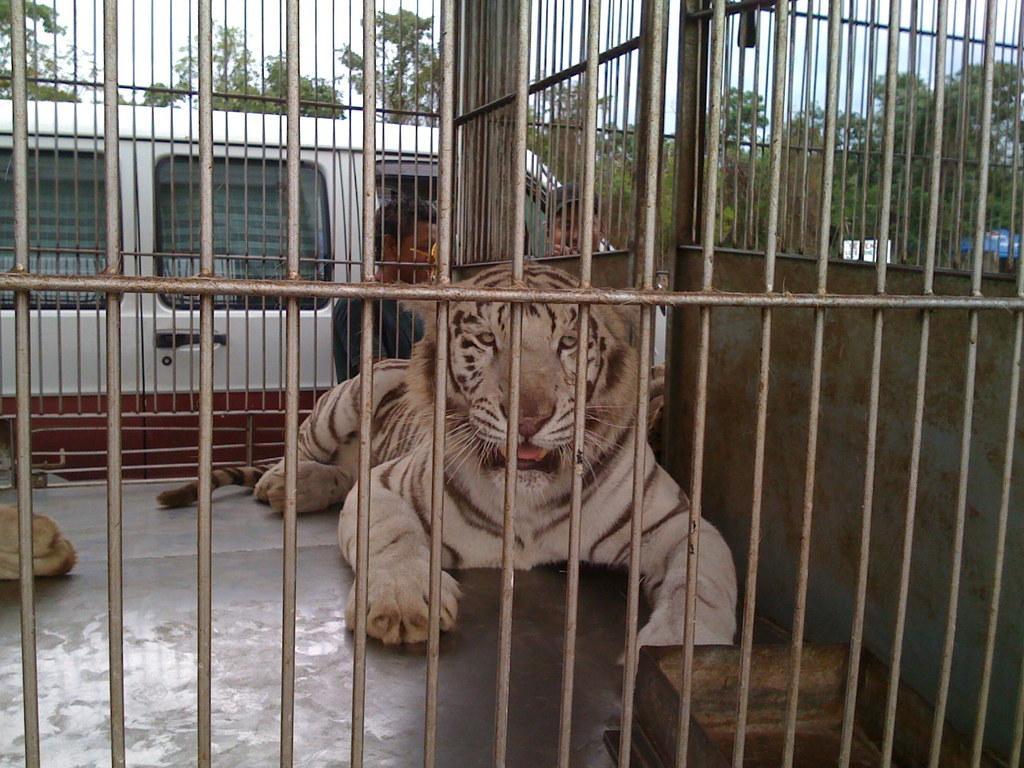How would you summarize this image in a sentence or two? In this image I can see an iron cage and in it I can see a white tiger. In background I can see two men are standing, a white vehicle, number of trees and few other things. 